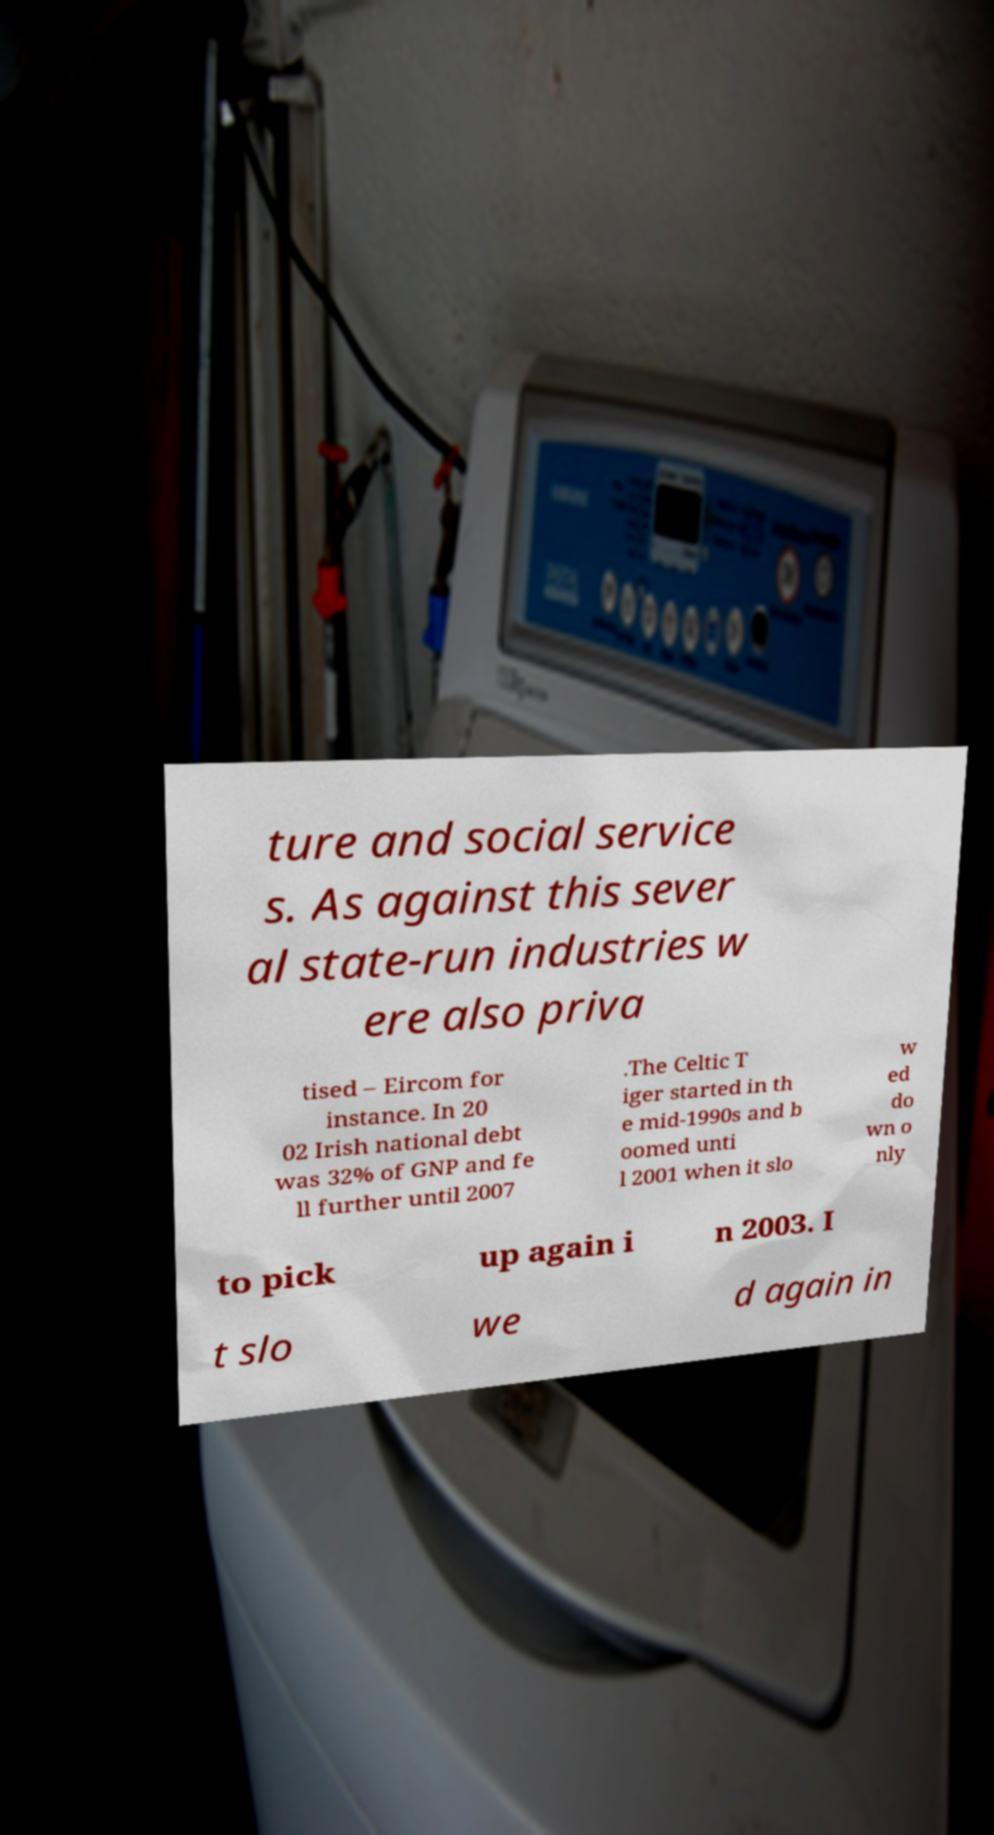Could you assist in decoding the text presented in this image and type it out clearly? ture and social service s. As against this sever al state-run industries w ere also priva tised – Eircom for instance. In 20 02 Irish national debt was 32% of GNP and fe ll further until 2007 .The Celtic T iger started in th e mid-1990s and b oomed unti l 2001 when it slo w ed do wn o nly to pick up again i n 2003. I t slo we d again in 